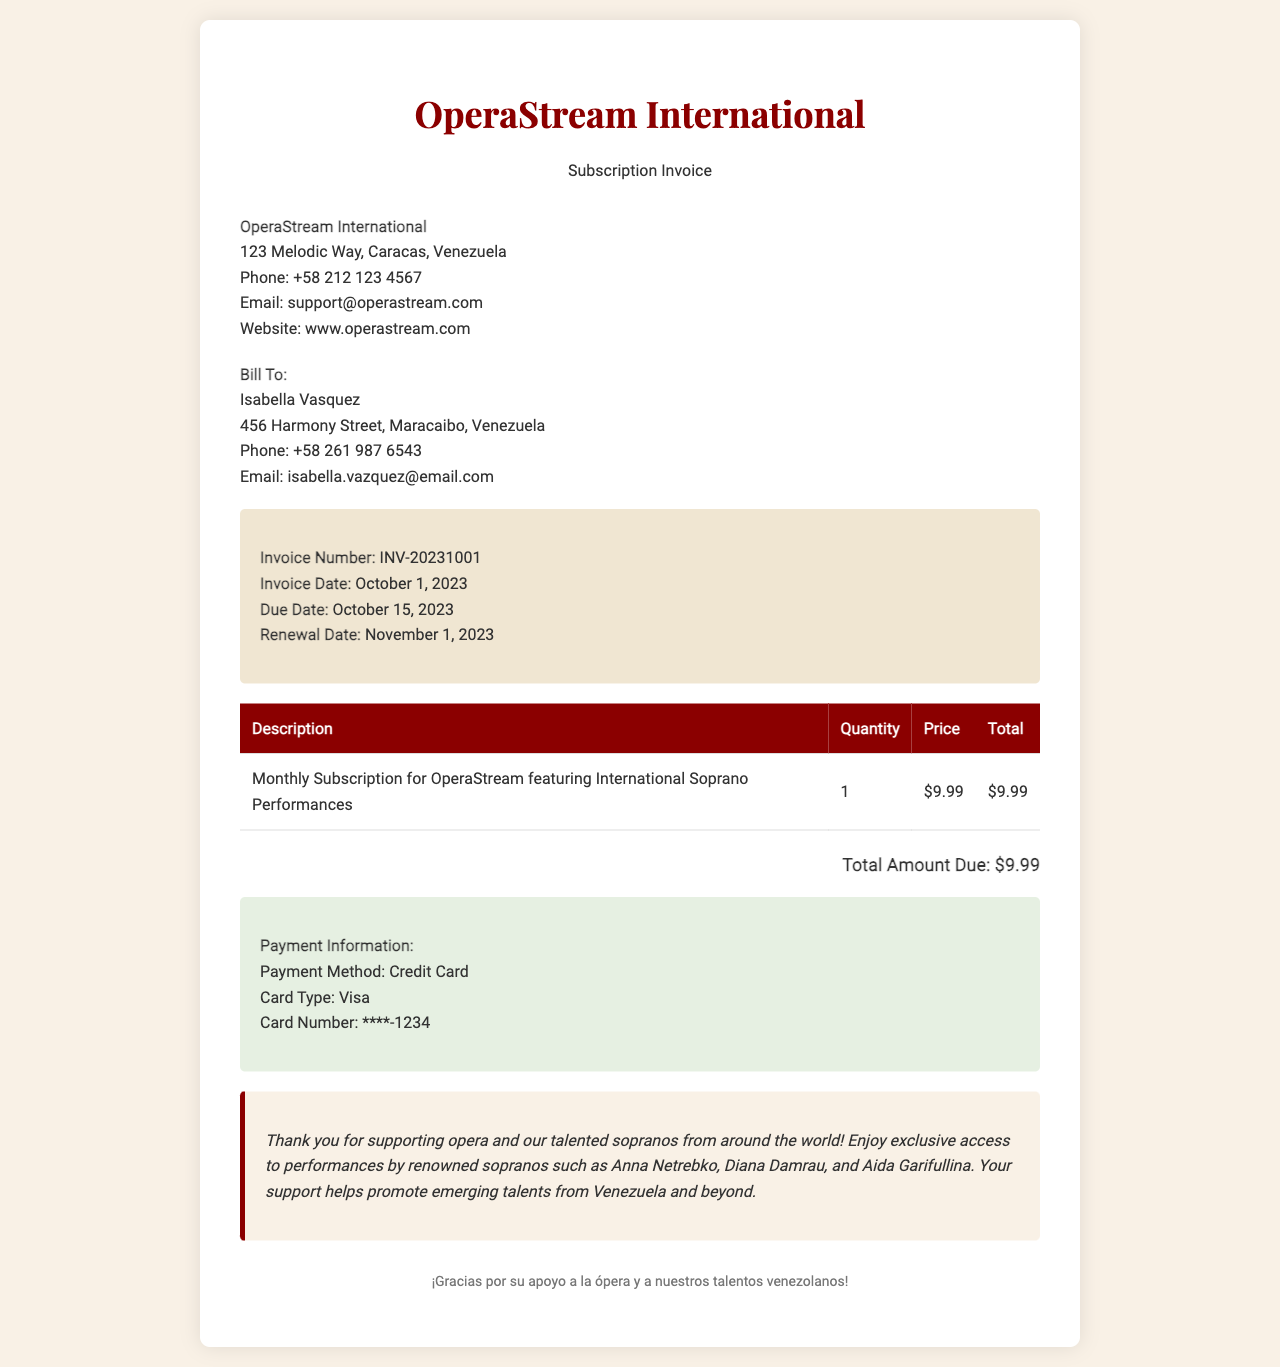What is the invoice number? The invoice number is listed prominently in the invoice details section, which is INV-20231001.
Answer: INV-20231001 What is the total amount due? The total amount due is stated at the bottom of the invoice, which is $9.99.
Answer: $9.99 What is the renewal date? The renewal date is mentioned as the date when the subscription will renew, which is November 1, 2023.
Answer: November 1, 2023 Who is the customer? The customer information section provides the name of the individual being billed, which is Isabella Vasquez.
Answer: Isabella Vasquez What email is provided for OperaStream International? The company information section includes their contact email, which is support@operastream.com.
Answer: support@operastream.com How often is the subscription billed? The description of the service outlines that it is a monthly subscription, indicating the frequency of billing.
Answer: Monthly What payment method is used? The payment information section specifies the method of payment, which is Credit Card.
Answer: Credit Card Who are some of the renowned sopranos mentioned in the notes? The notes section highlights several famous sopranos, including Anna Netrebko, Diana Damrau, and Aida Garifullina.
Answer: Anna Netrebko, Diana Damrau, Aida Garifullina What is the due date for this invoice? The due date is marked in the invoice details and is set for October 15, 2023.
Answer: October 15, 2023 